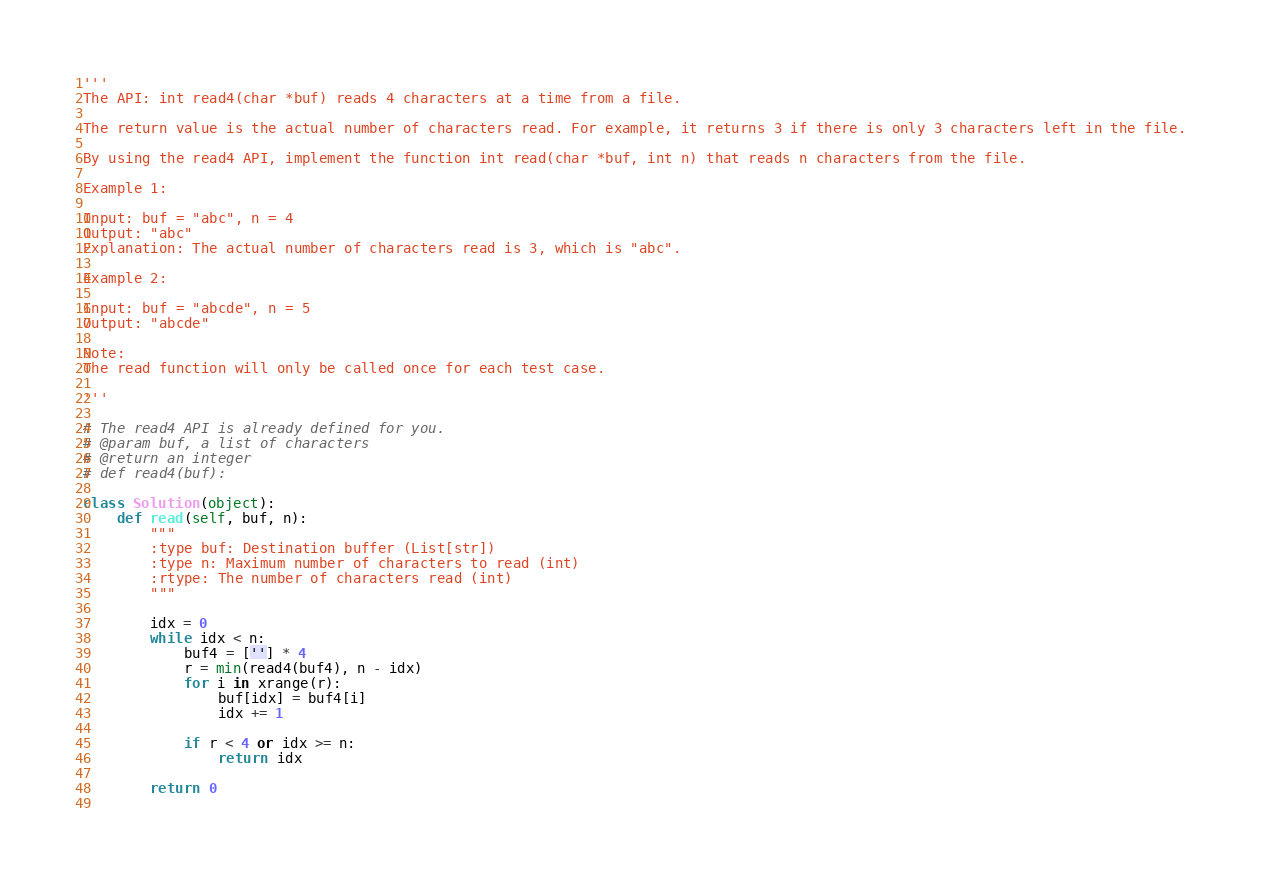<code> <loc_0><loc_0><loc_500><loc_500><_Python_>'''
The API: int read4(char *buf) reads 4 characters at a time from a file.

The return value is the actual number of characters read. For example, it returns 3 if there is only 3 characters left in the file.

By using the read4 API, implement the function int read(char *buf, int n) that reads n characters from the file.

Example 1:

Input: buf = "abc", n = 4
Output: "abc"
Explanation: The actual number of characters read is 3, which is "abc".

Example 2:

Input: buf = "abcde", n = 5 
Output: "abcde"

Note:
The read function will only be called once for each test case.

'''

# The read4 API is already defined for you.
# @param buf, a list of characters
# @return an integer
# def read4(buf):

class Solution(object):
    def read(self, buf, n):
        """
        :type buf: Destination buffer (List[str])
        :type n: Maximum number of characters to read (int)
        :rtype: The number of characters read (int)
        """
        
        idx = 0
        while idx < n:
            buf4 = [''] * 4
            r = min(read4(buf4), n - idx)
            for i in xrange(r):
                buf[idx] = buf4[i]
                idx += 1
                
            if r < 4 or idx >= n:
                return idx
            
        return 0
            
</code> 